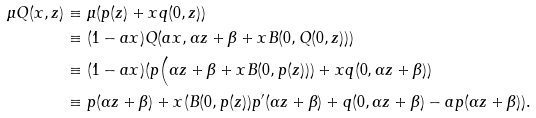Convert formula to latex. <formula><loc_0><loc_0><loc_500><loc_500>\mu Q ( x , z ) & \equiv \mu ( p ( z ) + x q ( 0 , z ) ) \\ & \equiv ( 1 - a x ) Q ( a x , \alpha z + \beta + x B ( 0 , Q ( 0 , z ) ) ) \\ & \equiv ( 1 - a x ) ( p \Big ( \alpha z + \beta + x B ( 0 , p ( z ) ) ) + x q ( 0 , \alpha z + \beta ) ) \\ & \equiv p ( \alpha z + \beta ) + x ( B ( 0 , p ( z ) ) p ^ { \prime } ( \alpha z + \beta ) + q ( 0 , \alpha z + \beta ) - a p ( \alpha z + \beta ) ) . \\</formula> 